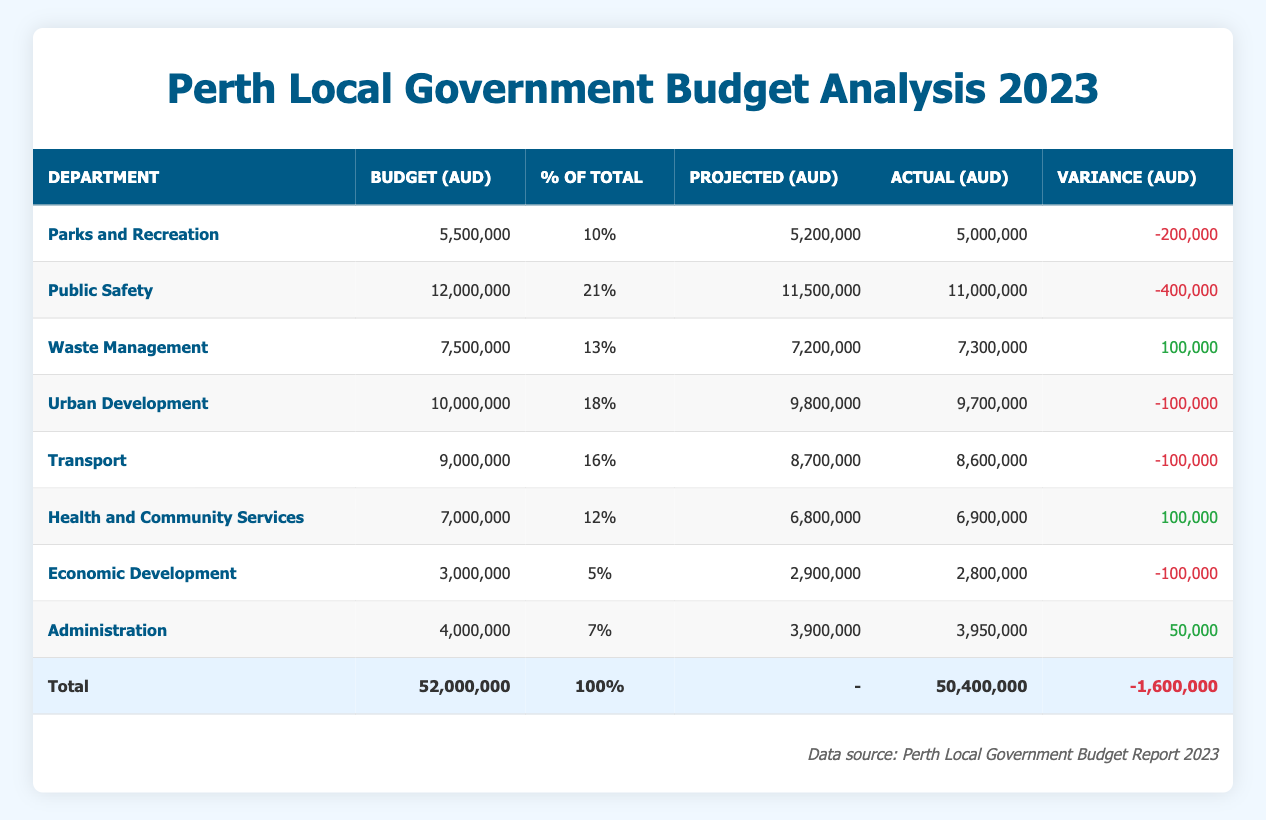What is the total budget for the various departments? The total budget for the departments is stated in the table under the "Total" row, which shows a Budget of 52,000,000.
Answer: 52,000,000 Which department has the highest budget? Looking at the Budget column, Public Safety has the highest budget of 12,000,000.
Answer: Public Safety What is the variance for the Health and Community Services department? The variance for Health and Community Services is shown in the Variance column, which indicates a positive variance of 100,000.
Answer: 100,000 What is the total actual expenditure across all departments? The Total Actual Expenditure is presented in the Total row under the Actual column, which lists 50,400,000 as the total.
Answer: 50,400,000 Which department had a negative variance? Multiple departments show negative variance. By reviewing the Variance column, we can see that Parks and Recreation, Public Safety, Urban Development, Transport, and Economic Development all have negative variances.
Answer: Parks and Recreation, Public Safety, Urban Development, Transport, Economic Development What percentage of the total budget is allocated to Waste Management? Waste Management is listed under the % of Total column, where it shows 13%.
Answer: 13% What is the total variance across all departments? The Total Variance is indicated in the Total row under the Variance column, which states a total of -1,600,000, meaning expenditures were below the budget.
Answer: -1,600,000 Which department spent more than its projected expenditure? Health and Community Services and Waste Management are the departments where actual expenditures exceeded the projected expenditures: for Health and Community Services, the actual is 6,900,000 against a projection of 6,800,000, and Waste Management's actual is 7,300,000 against a projection of 7,200,000.
Answer: Health and Community Services, Waste Management How much less did the Public Safety department spend compared to its budget? The budget for Public Safety is 12,000,000, and the actual expenditure is 11,000,000. The difference (12,000,000 - 11,000,000) is 1,000,000, meaning it spent 1,000,000 less than its budget.
Answer: 1,000,000 